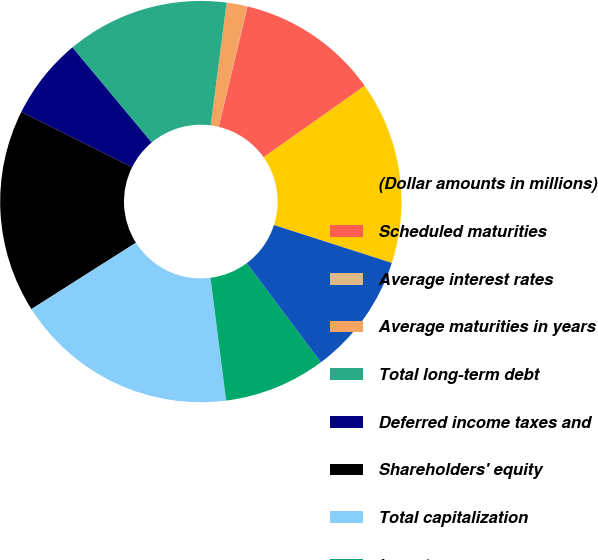Convert chart. <chart><loc_0><loc_0><loc_500><loc_500><pie_chart><fcel>(Dollar amounts in millions)<fcel>Scheduled maturities<fcel>Average interest rates<fcel>Average maturities in years<fcel>Total long-term debt<fcel>Deferred income taxes and<fcel>Shareholders' equity<fcel>Total capitalization<fcel>Long-term<fcel>Total unused committed credit<nl><fcel>14.74%<fcel>11.47%<fcel>0.02%<fcel>1.66%<fcel>13.11%<fcel>6.57%<fcel>16.38%<fcel>18.01%<fcel>8.2%<fcel>9.84%<nl></chart> 